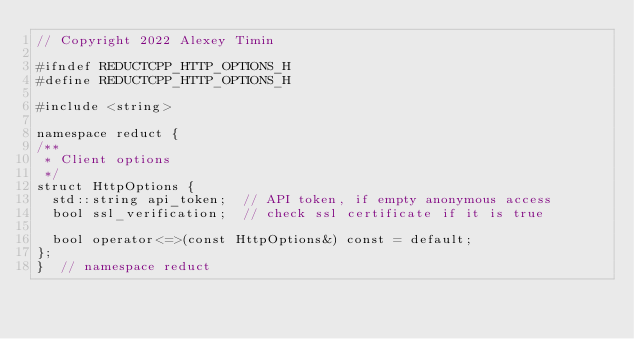Convert code to text. <code><loc_0><loc_0><loc_500><loc_500><_C_>// Copyright 2022 Alexey Timin

#ifndef REDUCTCPP_HTTP_OPTIONS_H
#define REDUCTCPP_HTTP_OPTIONS_H

#include <string>

namespace reduct {
/**
 * Client options
 */
struct HttpOptions {
  std::string api_token;  // API token, if empty anonymous access
  bool ssl_verification;  // check ssl certificate if it is true

  bool operator<=>(const HttpOptions&) const = default;
};
}  // namespace reduct</code> 